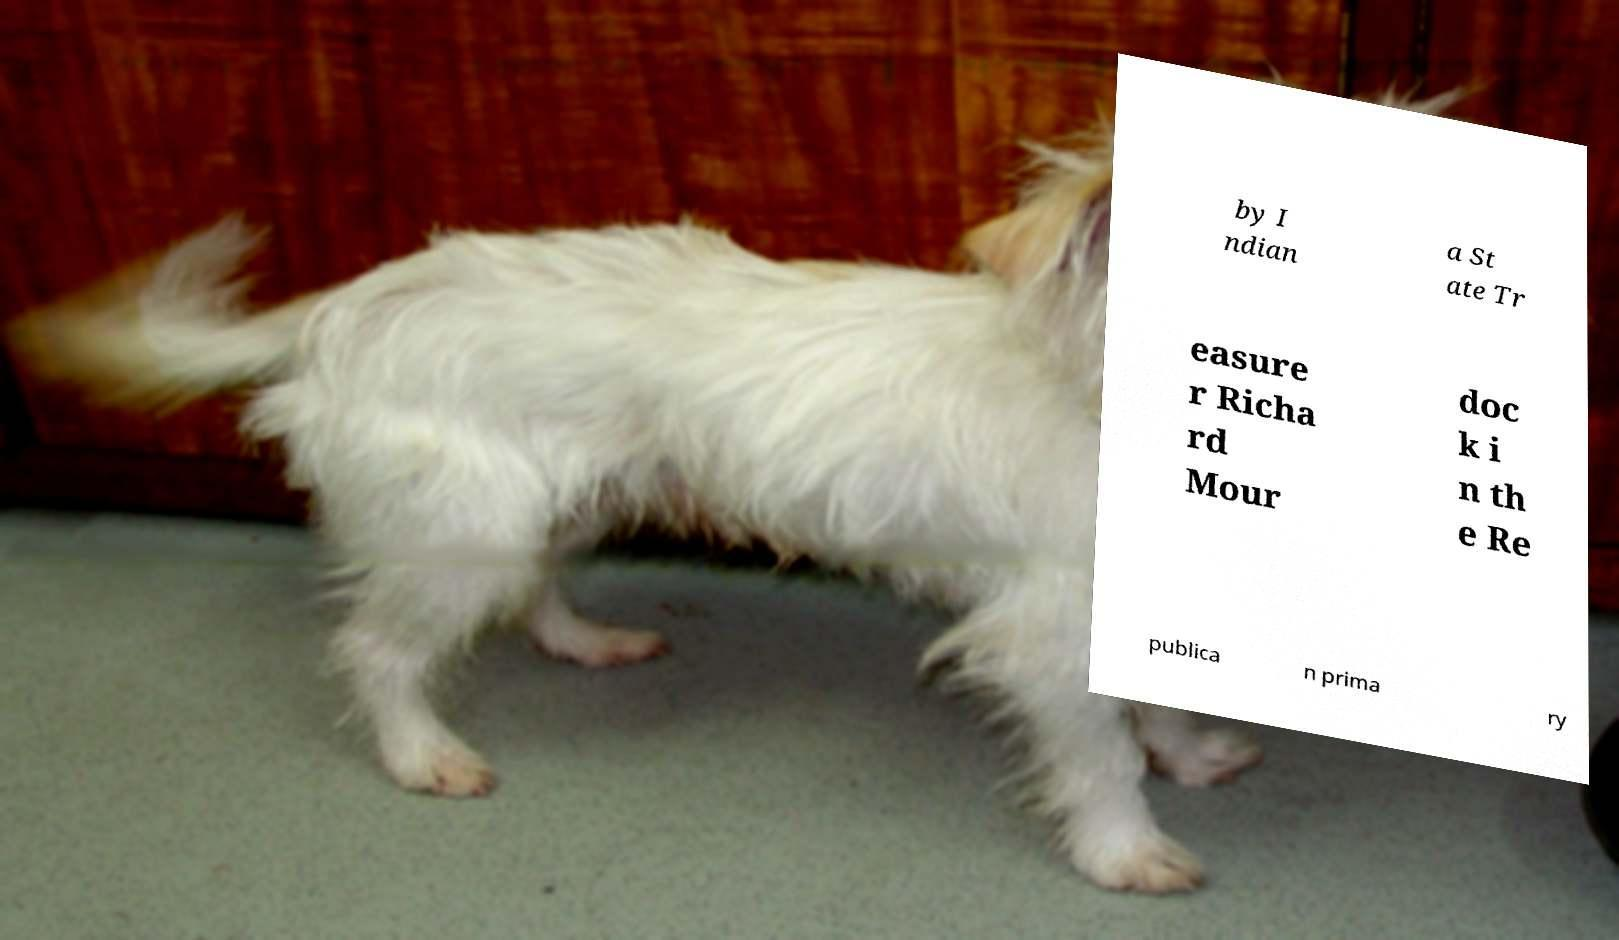Can you accurately transcribe the text from the provided image for me? by I ndian a St ate Tr easure r Richa rd Mour doc k i n th e Re publica n prima ry 